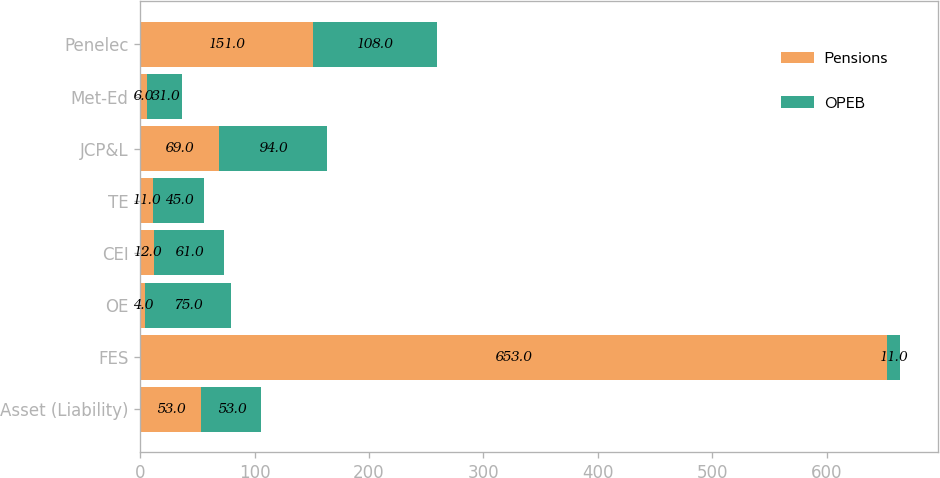Convert chart. <chart><loc_0><loc_0><loc_500><loc_500><stacked_bar_chart><ecel><fcel>Asset (Liability)<fcel>FES<fcel>OE<fcel>CEI<fcel>TE<fcel>JCP&L<fcel>Met-Ed<fcel>Penelec<nl><fcel>Pensions<fcel>53<fcel>653<fcel>4<fcel>12<fcel>11<fcel>69<fcel>6<fcel>151<nl><fcel>OPEB<fcel>53<fcel>11<fcel>75<fcel>61<fcel>45<fcel>94<fcel>31<fcel>108<nl></chart> 